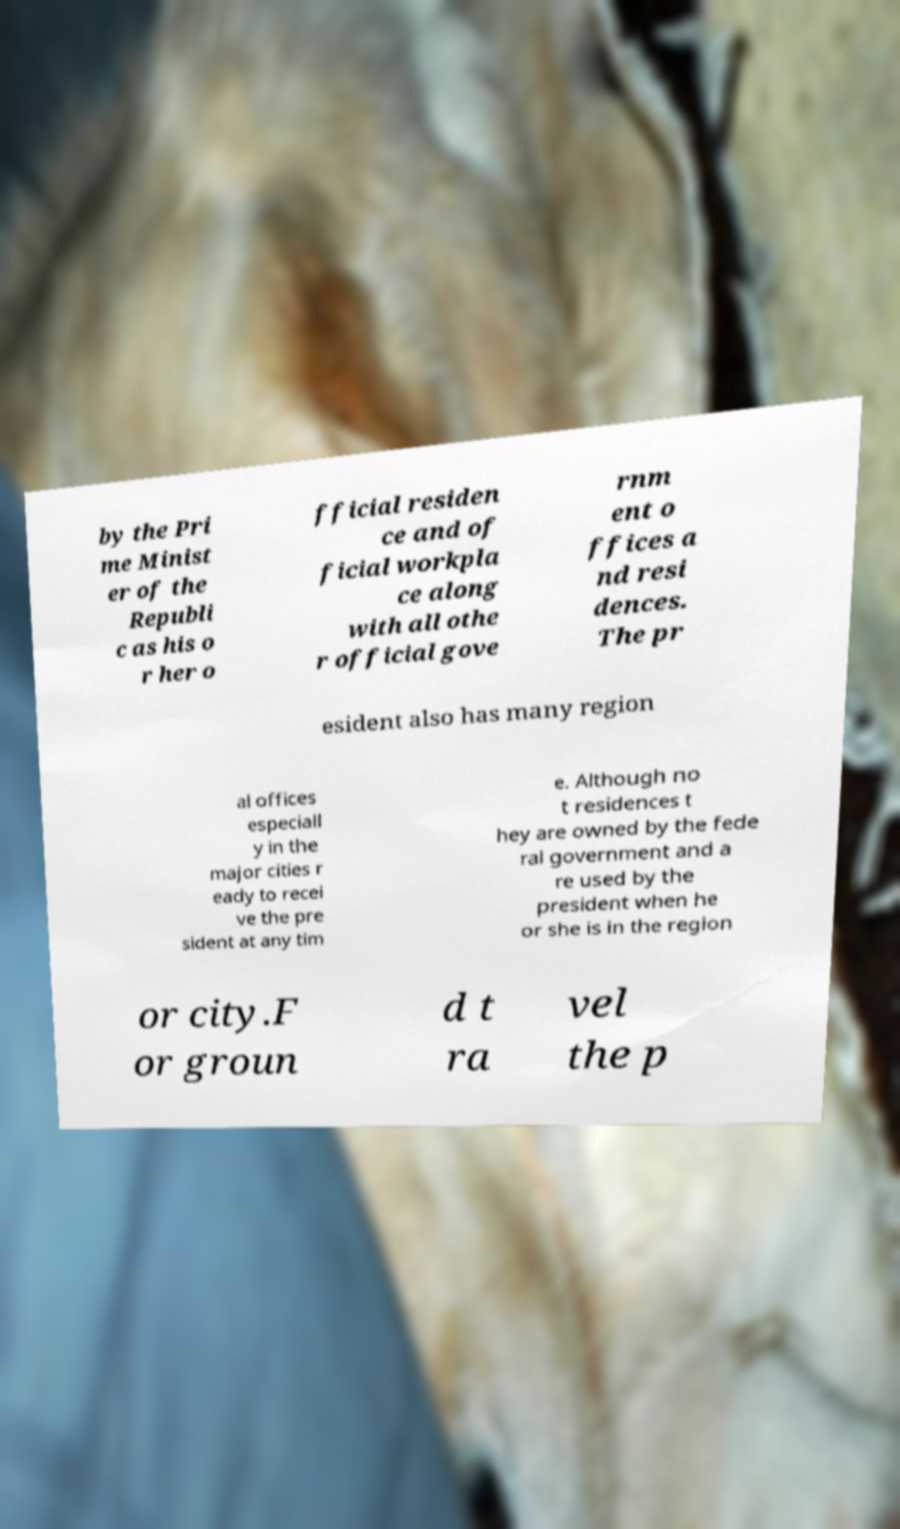Can you accurately transcribe the text from the provided image for me? by the Pri me Minist er of the Republi c as his o r her o fficial residen ce and of ficial workpla ce along with all othe r official gove rnm ent o ffices a nd resi dences. The pr esident also has many region al offices especiall y in the major cities r eady to recei ve the pre sident at any tim e. Although no t residences t hey are owned by the fede ral government and a re used by the president when he or she is in the region or city.F or groun d t ra vel the p 